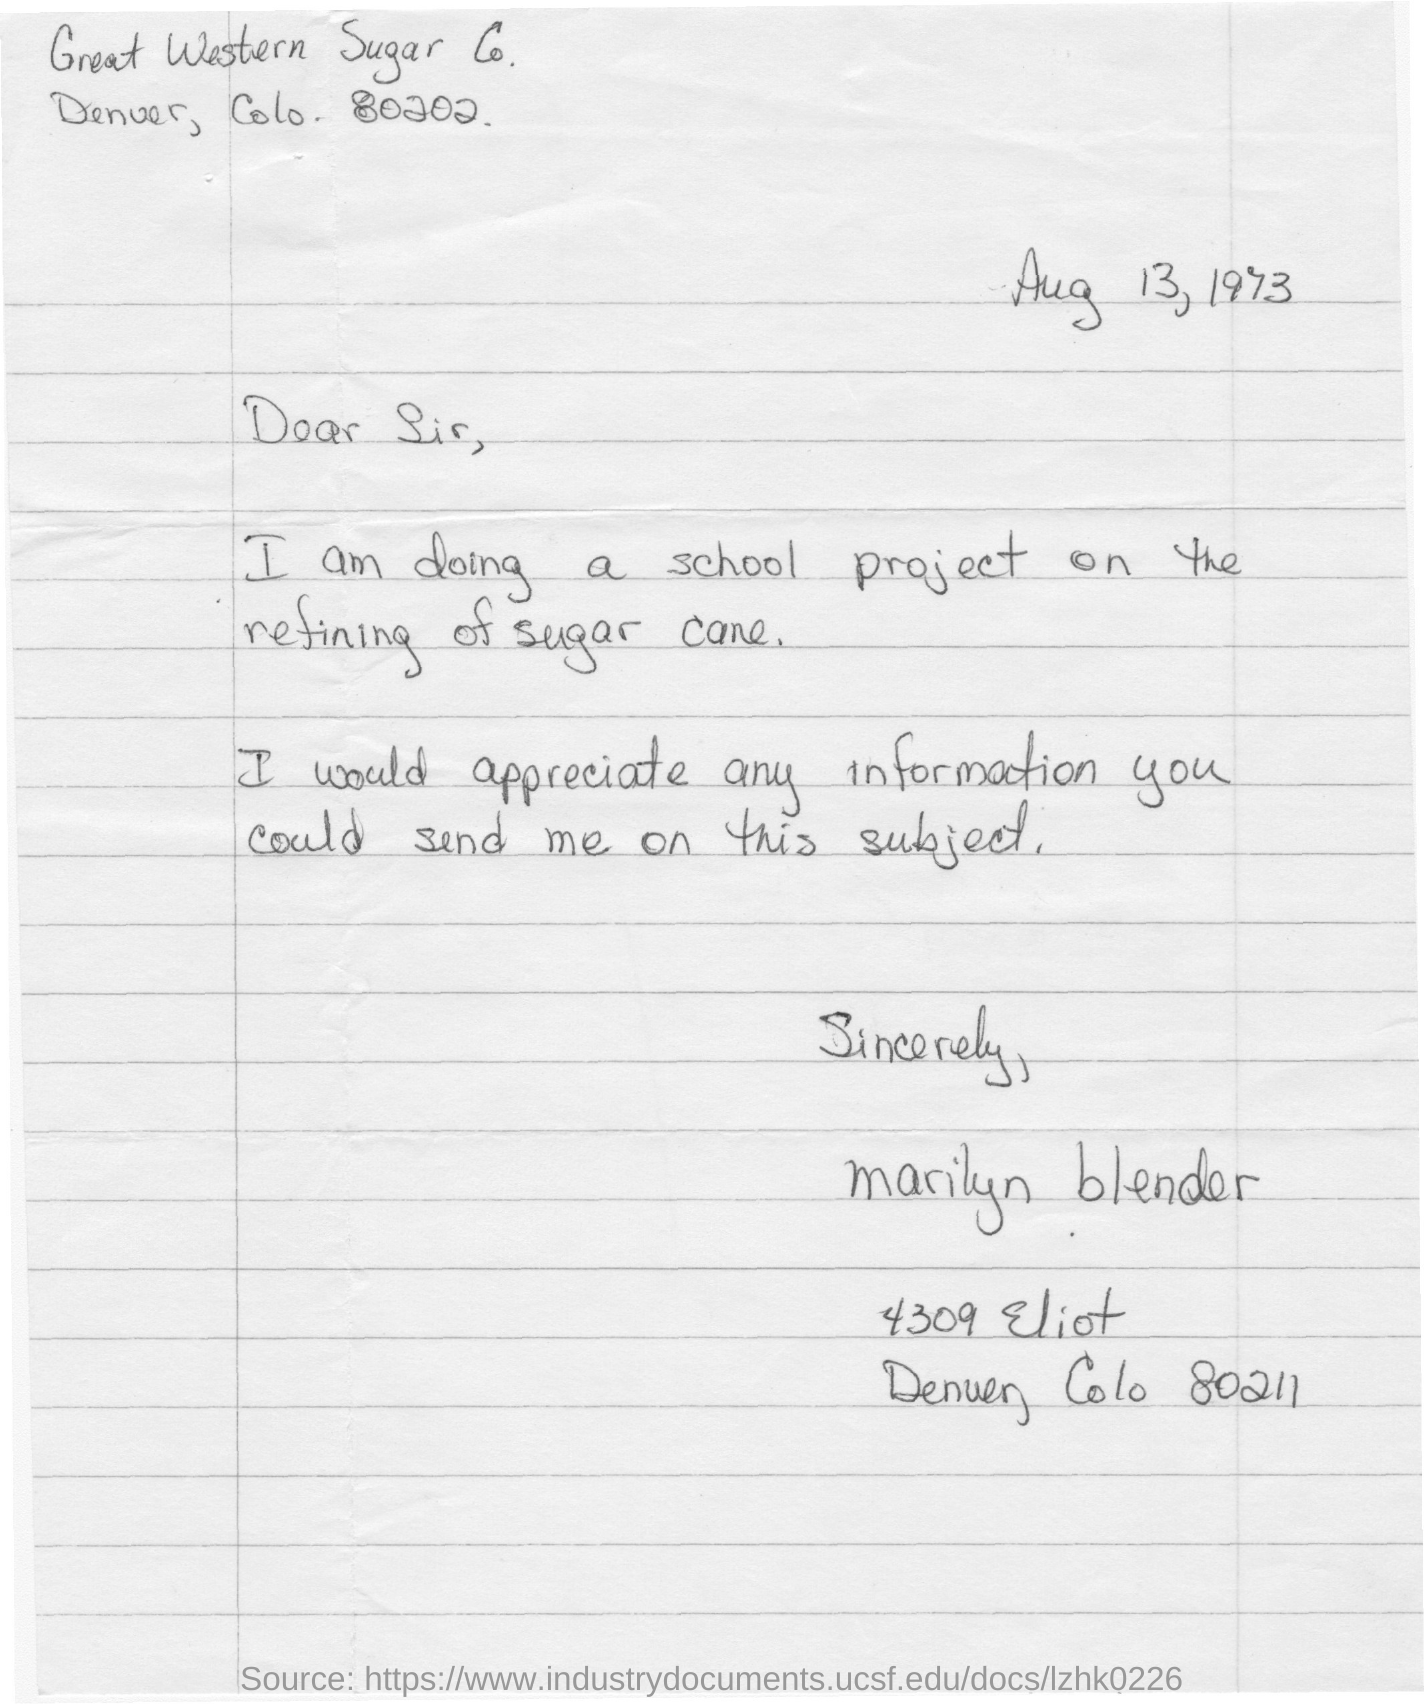Indicate a few pertinent items in this graphic. Marilyn Blender wrote the letter to the sugar company. The student is currently working on a school project focused on the refining of sugar cane. The date on the letter is August 13, 1973. The date mentioned in the letter is August 13, 1973. 